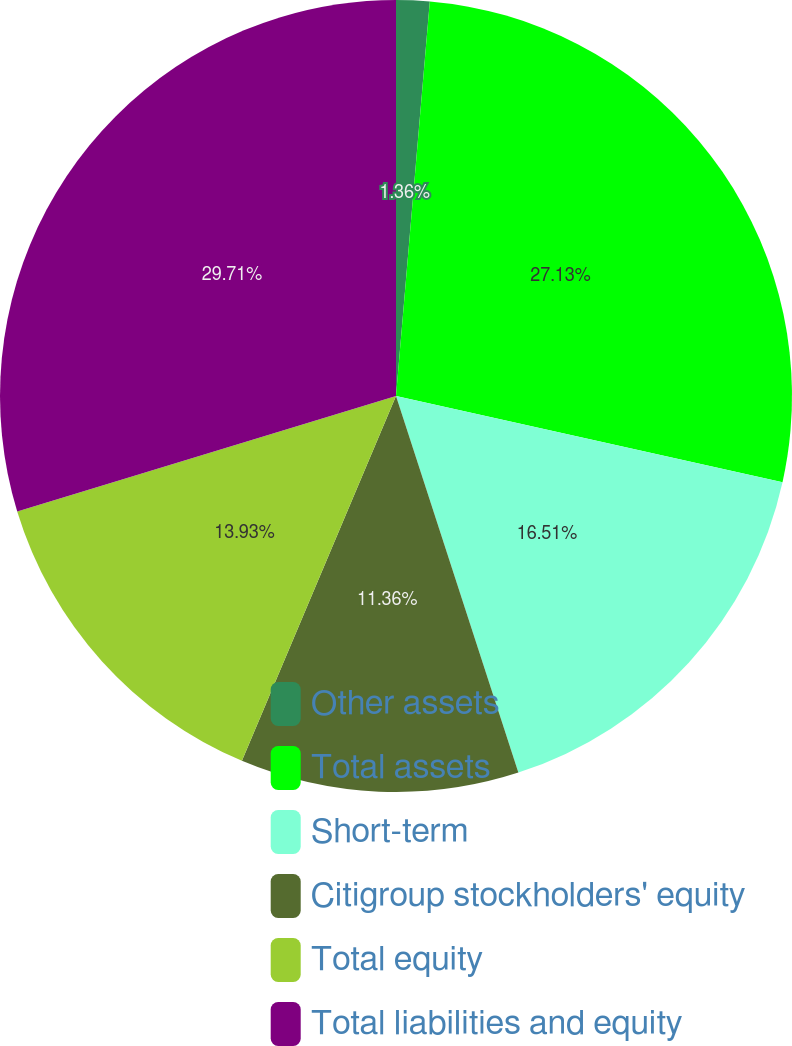Convert chart. <chart><loc_0><loc_0><loc_500><loc_500><pie_chart><fcel>Other assets<fcel>Total assets<fcel>Short-term<fcel>Citigroup stockholders' equity<fcel>Total equity<fcel>Total liabilities and equity<nl><fcel>1.36%<fcel>27.13%<fcel>16.51%<fcel>11.36%<fcel>13.93%<fcel>29.71%<nl></chart> 